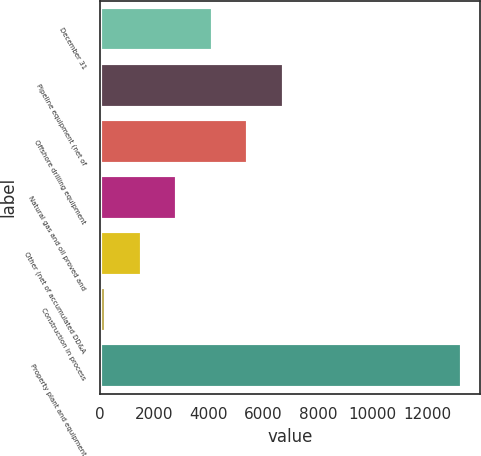Convert chart to OTSL. <chart><loc_0><loc_0><loc_500><loc_500><bar_chart><fcel>December 31<fcel>Pipeline equipment (net of<fcel>Offshore drilling equipment<fcel>Natural gas and oil proved and<fcel>Other (net of accumulated DD&A<fcel>Construction in process<fcel>Property plant and equipment<nl><fcel>4146<fcel>6754<fcel>5450<fcel>2842<fcel>1538<fcel>234<fcel>13274<nl></chart> 